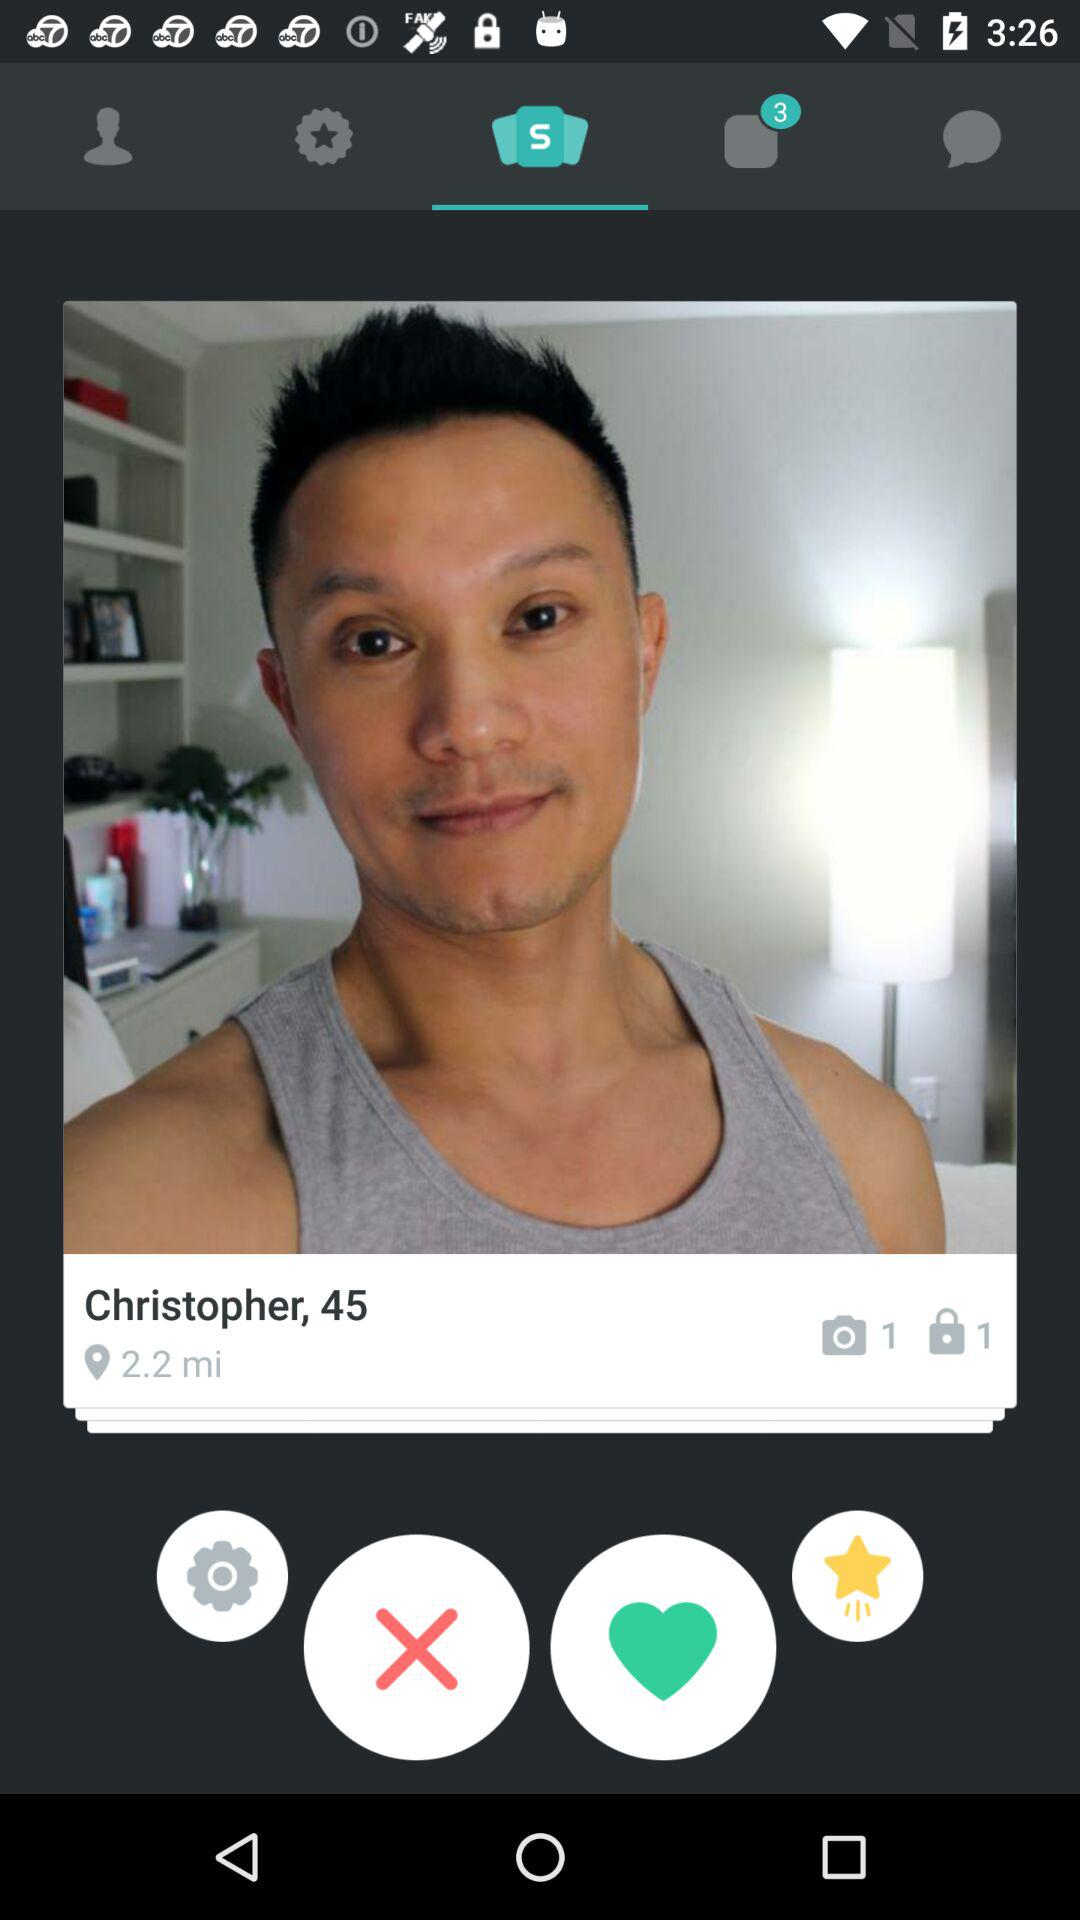What is the distance? The distance is 2.2 miles. 